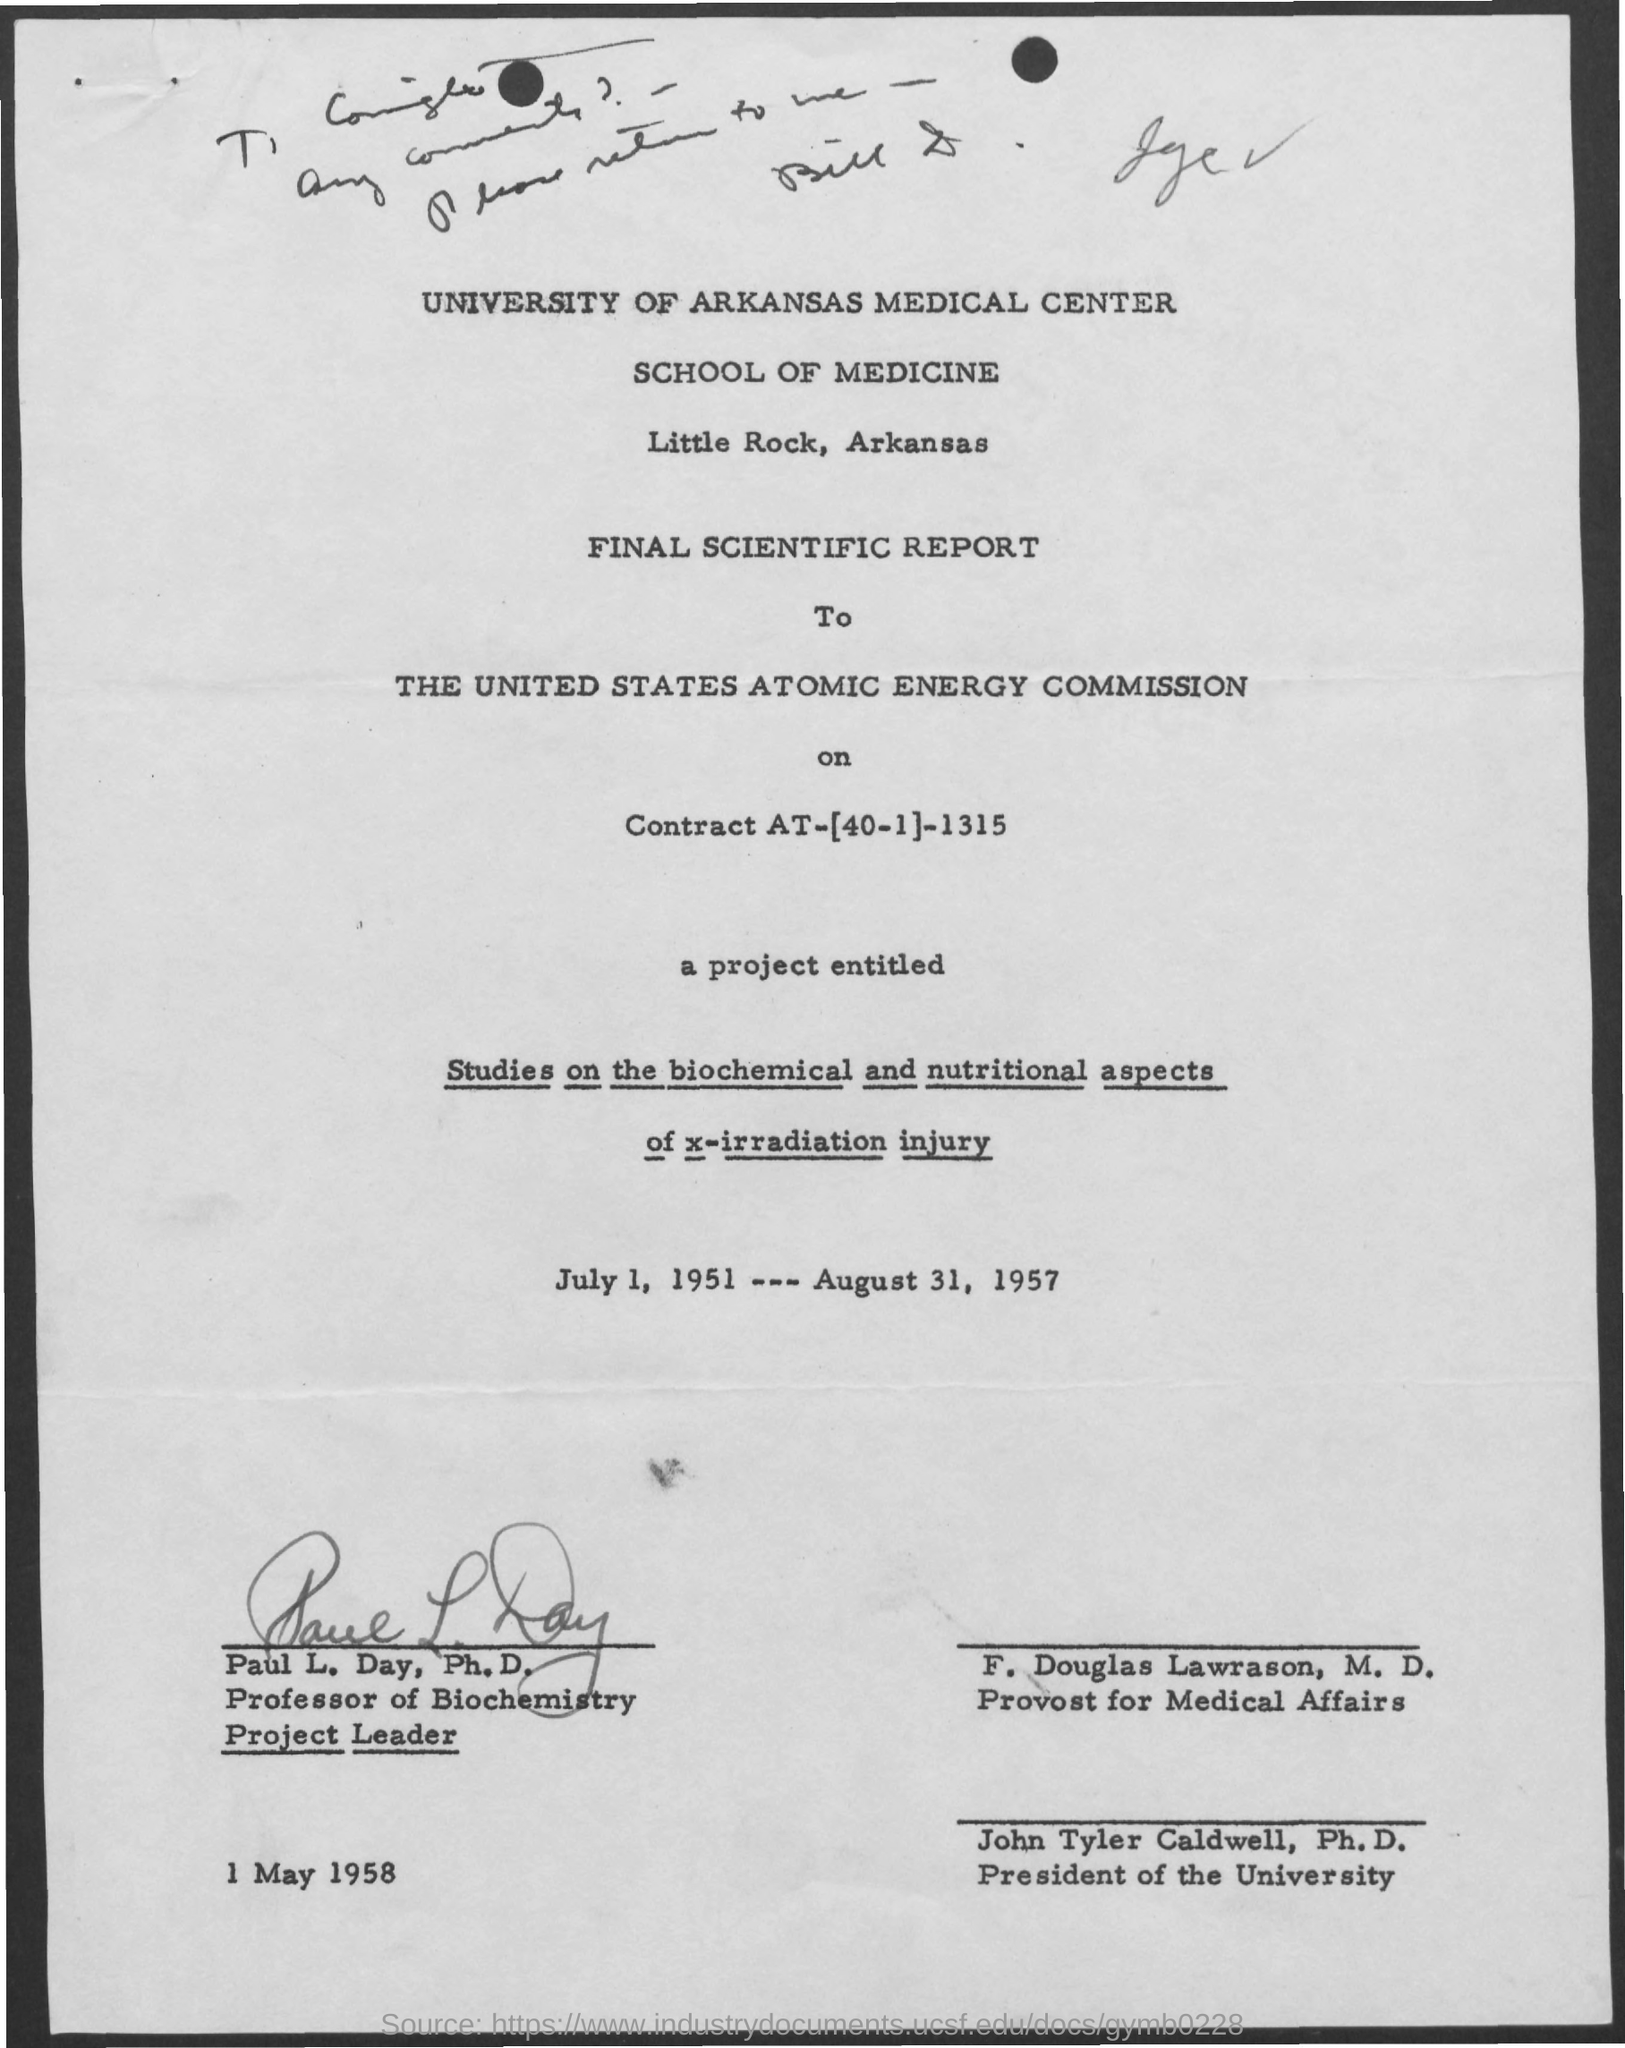Indicate a few pertinent items in this graphic. The project began on July 1, 1951 and concluded on August 31, 1957. 